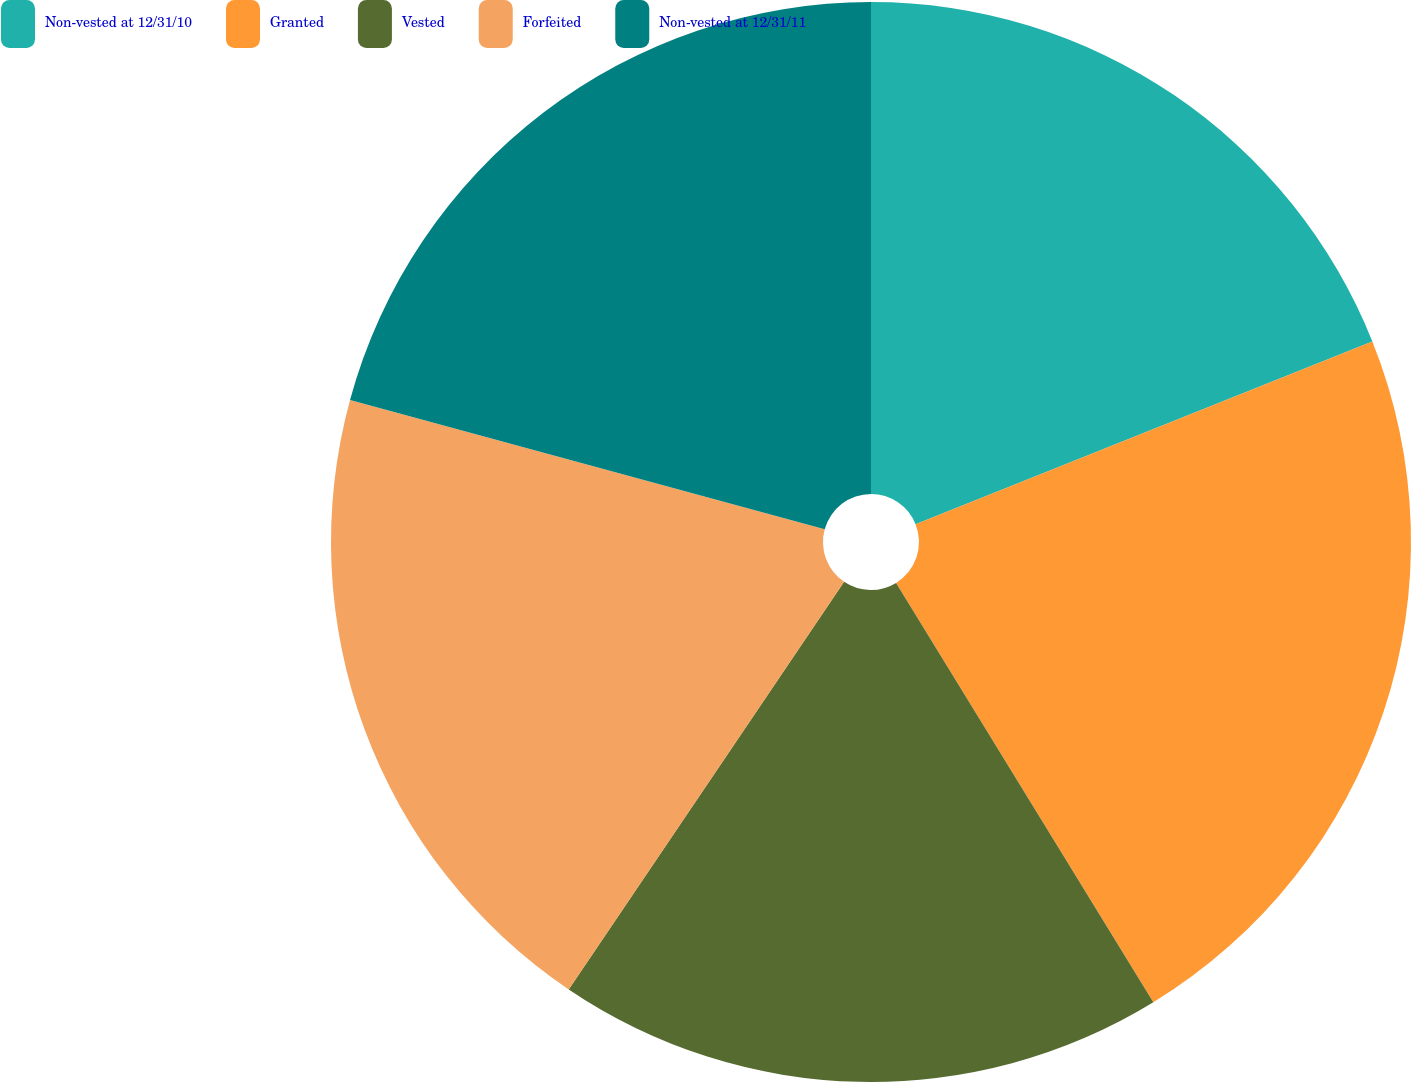Convert chart to OTSL. <chart><loc_0><loc_0><loc_500><loc_500><pie_chart><fcel>Non-vested at 12/31/10<fcel>Granted<fcel>Vested<fcel>Forfeited<fcel>Non-vested at 12/31/11<nl><fcel>18.94%<fcel>22.3%<fcel>18.21%<fcel>19.78%<fcel>20.76%<nl></chart> 